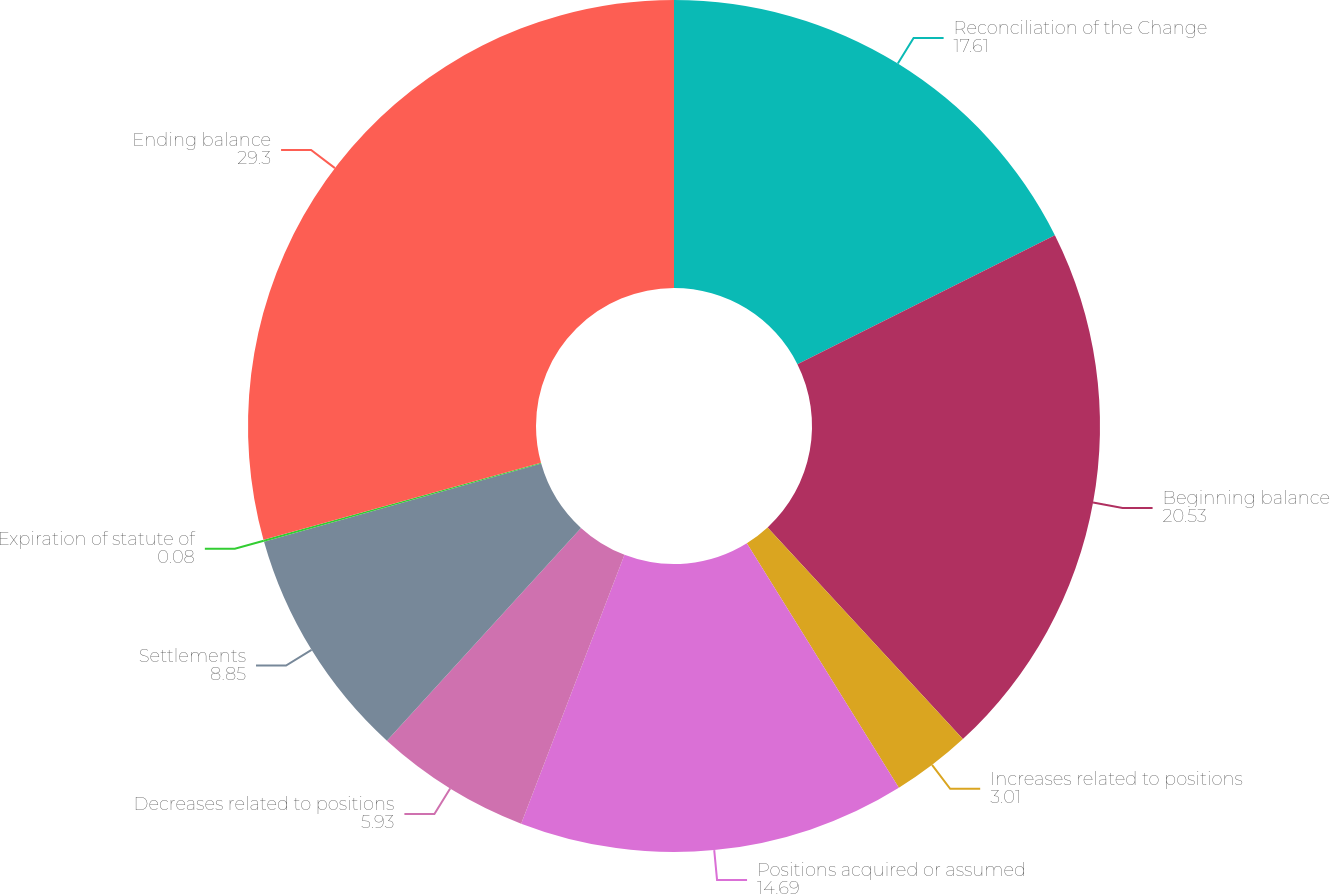Convert chart to OTSL. <chart><loc_0><loc_0><loc_500><loc_500><pie_chart><fcel>Reconciliation of the Change<fcel>Beginning balance<fcel>Increases related to positions<fcel>Positions acquired or assumed<fcel>Decreases related to positions<fcel>Settlements<fcel>Expiration of statute of<fcel>Ending balance<nl><fcel>17.61%<fcel>20.53%<fcel>3.01%<fcel>14.69%<fcel>5.93%<fcel>8.85%<fcel>0.08%<fcel>29.3%<nl></chart> 